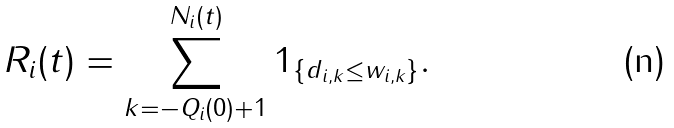<formula> <loc_0><loc_0><loc_500><loc_500>R _ { i } ( t ) = \sum _ { k = - Q _ { i } ( 0 ) + 1 } ^ { N _ { i } ( t ) } 1 _ { \{ d _ { i , k } \leq w _ { i , k } \} } .</formula> 